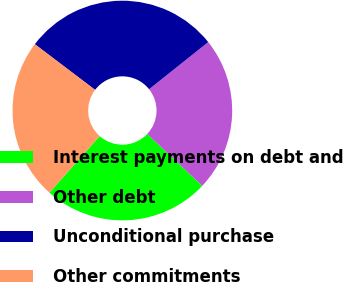Convert chart. <chart><loc_0><loc_0><loc_500><loc_500><pie_chart><fcel>Interest payments on debt and<fcel>Other debt<fcel>Unconditional purchase<fcel>Other commitments<nl><fcel>24.52%<fcel>22.74%<fcel>28.97%<fcel>23.76%<nl></chart> 